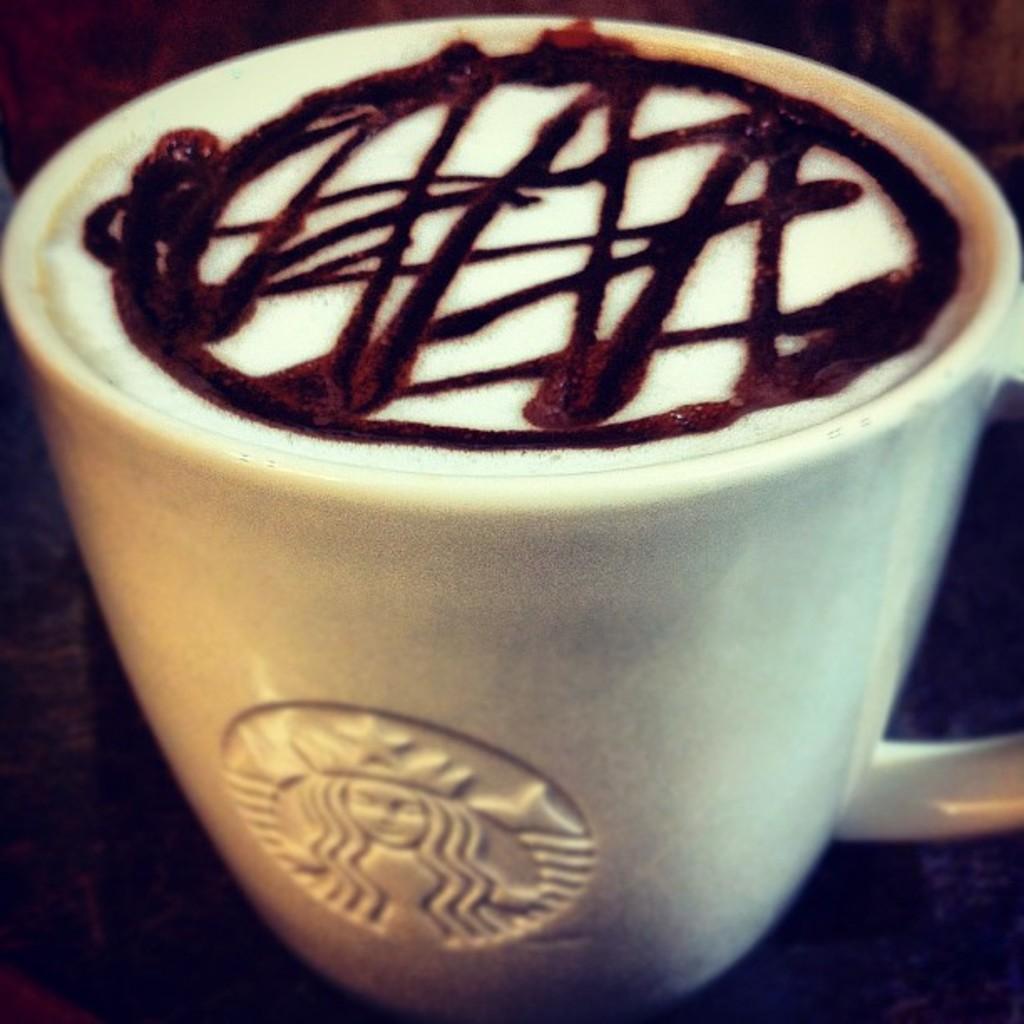Can you describe this image briefly? In this image, I can see a cup of coffee with latte art. At the bottom of the image, I can see the logo of Starbucks on a cup. 